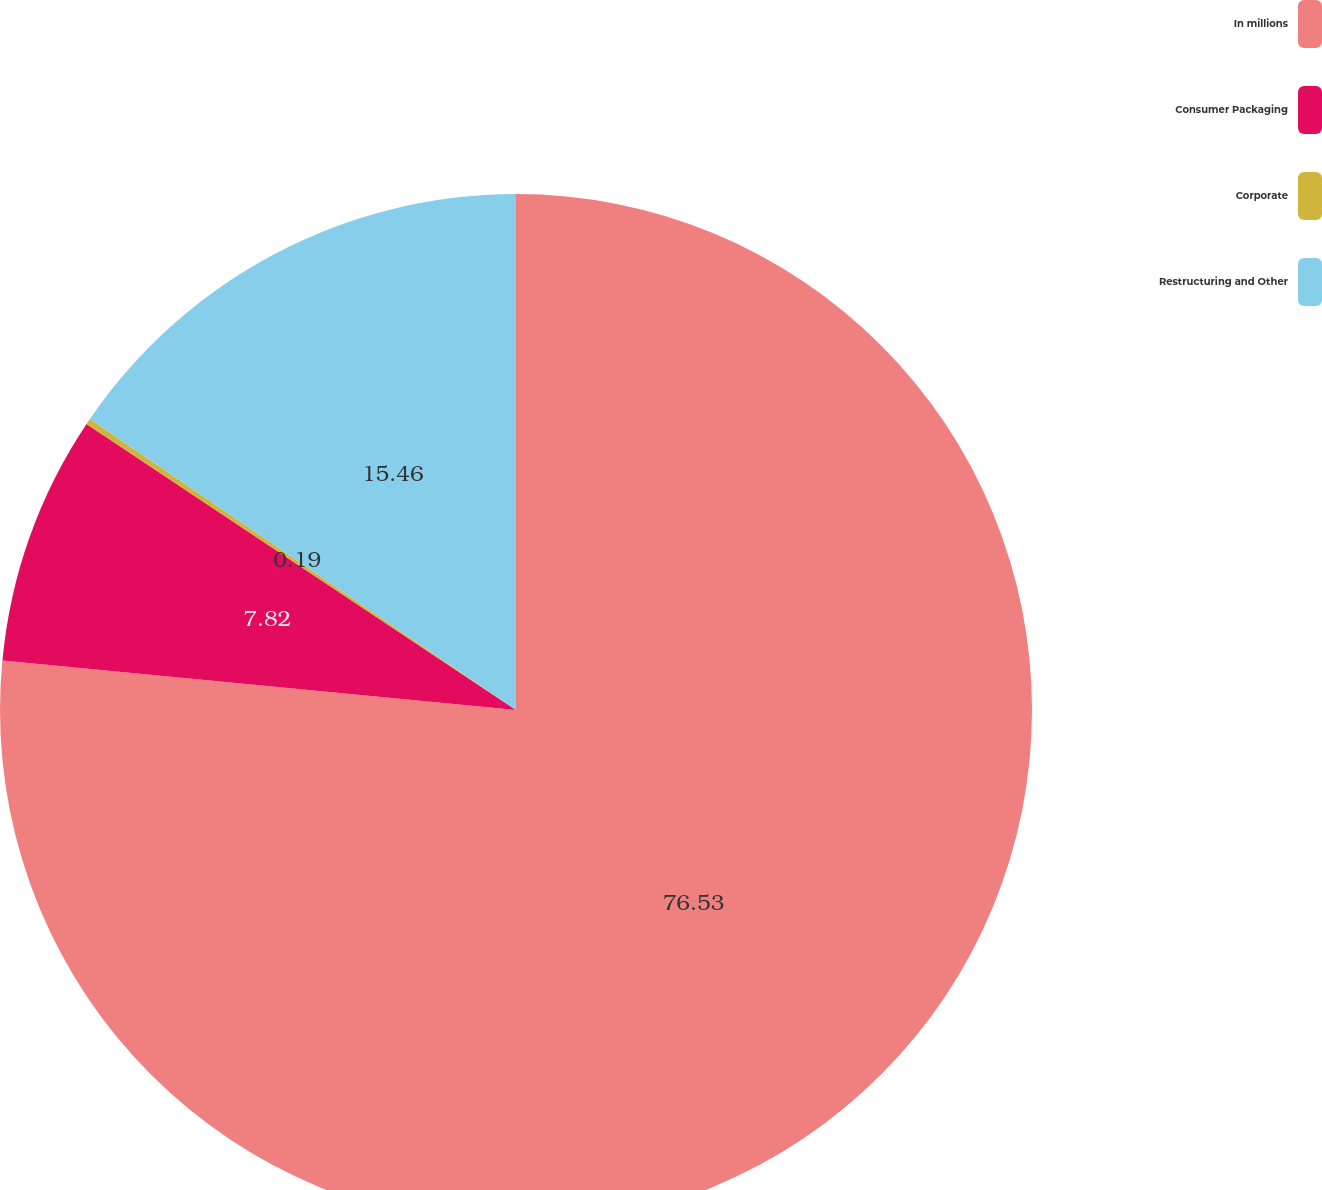Convert chart to OTSL. <chart><loc_0><loc_0><loc_500><loc_500><pie_chart><fcel>In millions<fcel>Consumer Packaging<fcel>Corporate<fcel>Restructuring and Other<nl><fcel>76.53%<fcel>7.82%<fcel>0.19%<fcel>15.46%<nl></chart> 